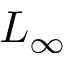Convert formula to latex. <formula><loc_0><loc_0><loc_500><loc_500>L _ { \infty }</formula> 